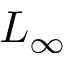Convert formula to latex. <formula><loc_0><loc_0><loc_500><loc_500>L _ { \infty }</formula> 